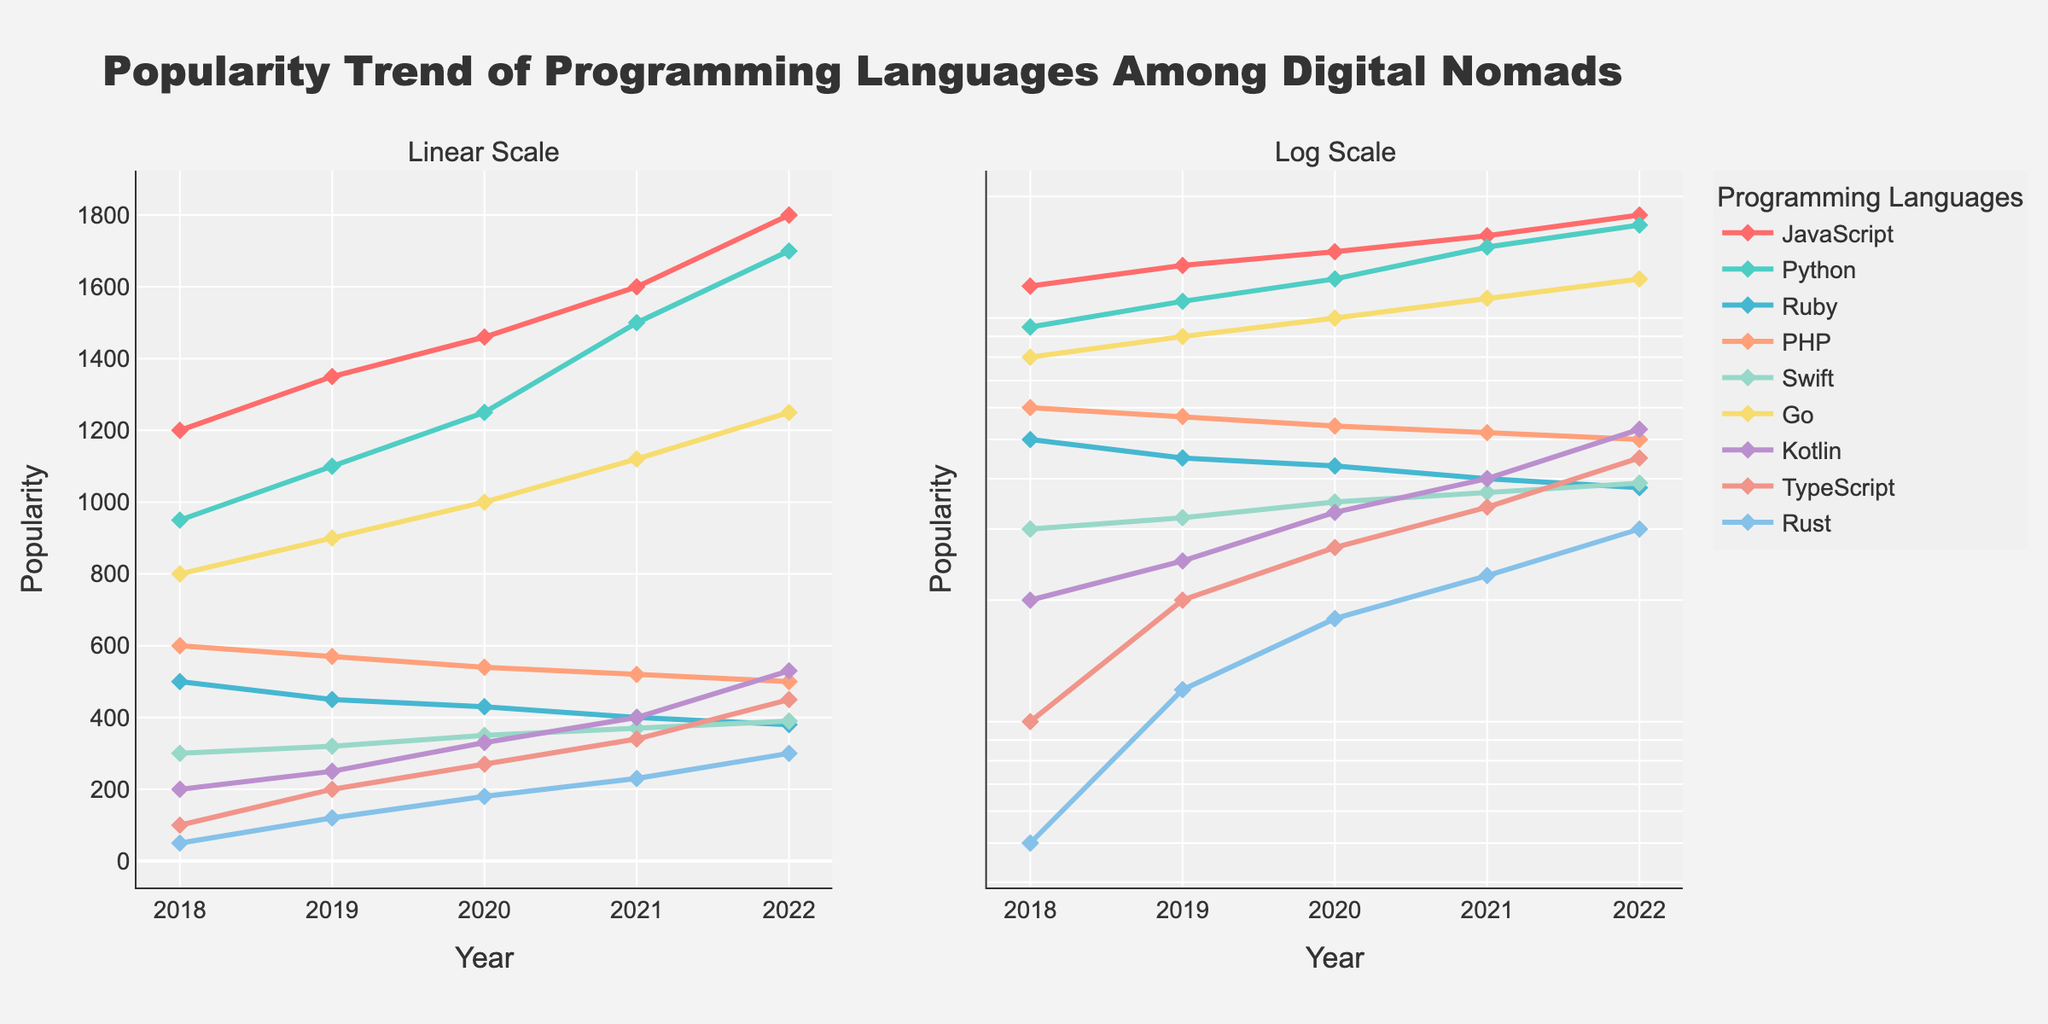How many years of data are shown in the plot? The x-axis in both subplots indicates the years, starting from 2018 to 2022. By counting these, you can determine the number of years.
Answer: 5 Which programming language shows a consistent decrease in popularity over the years? By observing the trends in both subplots, Ruby displays a decreasing trend from 500 in 2018 to 380 in 2022.
Answer: Ruby What is the range of popularity values shown on the y-axis of the log scale subplot? The y-axis on the log scale subplot shows values ranging from greater than 1 (minimum) to around 1800 (maximum) as indicated by the highest value.
Answer: >1 to 1800 Between Python and Go, which programming language has a higher popularity increase over the years? By comparing the trends, Python increased from 950 in 2018 to 1700 in 2022, while Go increased from 800 to 1250 in the same period. The increase for Python is 750, which is higher than Go's increase of 450.
Answer: Python What is the average popularity of Swift from 2018 to 2022? Sum the popularity values of Swift for each year: 300 + 320 + 350 + 370 + 390 = 1730. Then divide by the number of years (5): 1730/5 = 346.
Answer: 346 Which programming language shown has the lowest starting popularity in 2018? Look at the values for each language in 2018. Rust has the lowest value, starting at 50.
Answer: Rust Does TypeScript show an exponential growth pattern in popularity? Examine the trends in the log scale subplot. TypeScript's line appears to curve upwards, indicating exponential growth from 100 in 2018 to 450 in 2022.
Answer: Yes What is the median popularity value for JavaScript across the given years? The popularity values for JavaScript are 1200, 1350, 1460, 1600, and 1800. Arrange them in order and find the middle value: 1460.
Answer: 1460 On the linear scale subplot, which color is associated with Kotlin? By matching the color from the subplot, Kotlin is represented by a purple-like color.
Answer: Purple Which programming languages have their popularity values remain under 500 every year? By examining the trends, Ruby, PHP, Swift, Kotlin, TypeScript, and Rust all have values under 500 across all years.
Answer: Ruby, PHP, Swift, Kotlin, TypeScript, Rust 